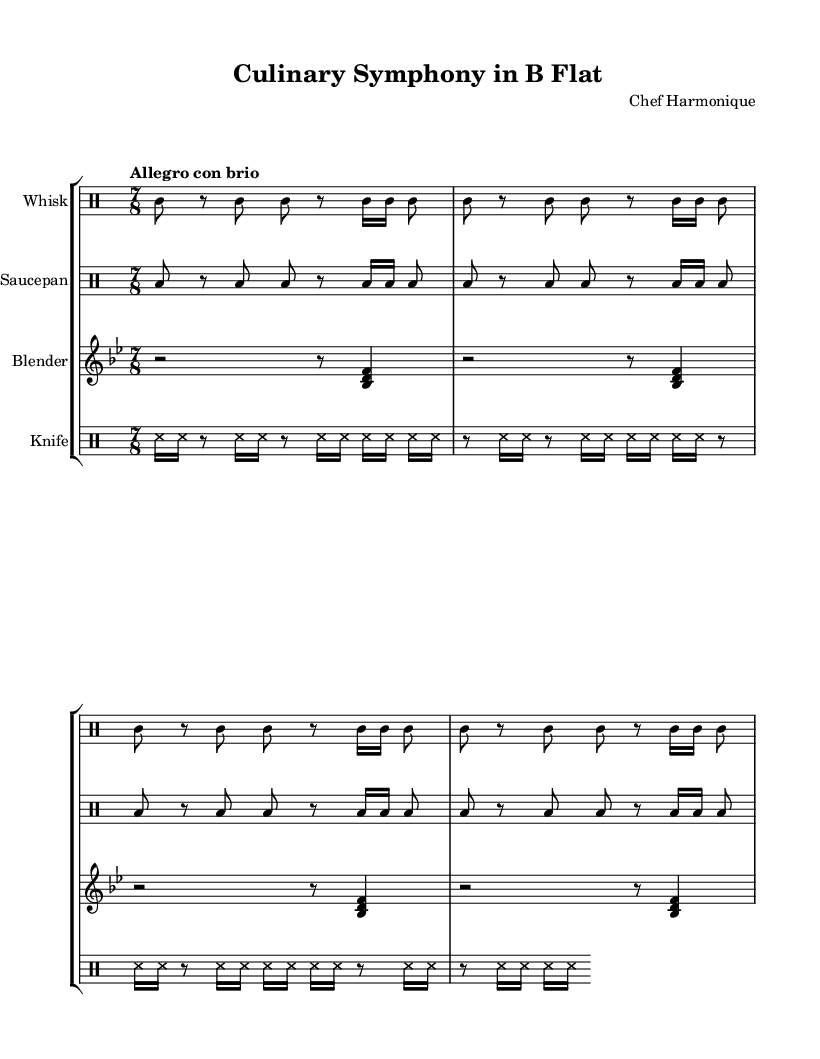What is the title of this piece? The title is prominently displayed at the top of the sheet music, labeled "Culinary Symphony in B Flat."
Answer: Culinary Symphony in B Flat What is the time signature of the Whisk part? The time signature is indicated at the beginning of the Whisk section and is shown as 7/8, which means there are seven eighth notes per measure.
Answer: 7/8 What instruments are used in this composition? The instruments are listed before each part in the sheet music, namely Whisk, Saucepan, Blender, and Knife.
Answer: Whisk, Saucepan, Blender, Knife What is the tempo marking for this score? The tempo marking is found at the beginning of the Whisk section, where it states "Allegro con brio," indicating a fast and lively tempo.
Answer: Allegro con brio How many times is the main theme repeated in the Whisk section? The Whisk part shows the main theme repeated four times, as specified by the "repeat unfold 4" instruction at the beginning of the section.
Answer: 4 What can we infer about the nature of the instruments used in this composition? The instruments used, such as Whisk, Saucepan, Blender, and Knife, suggest an experimental and avant-garde approach to composition, utilizing unconventional items for musical expression.
Answer: Experimental approach 